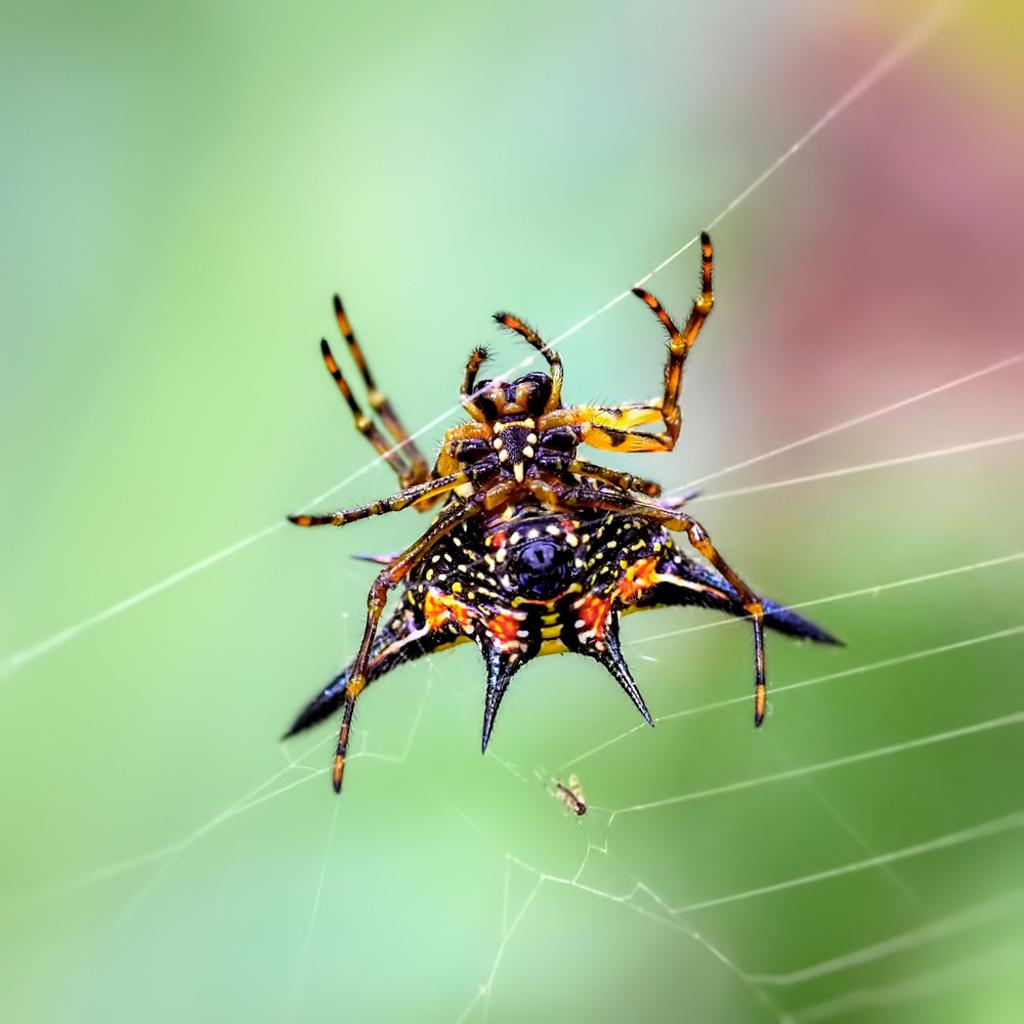What is the main subject of the image? The main subject of the image is a spider in a web. Where is the spider located in the image? The spider is in the web, which is in the center of the image. What type of cover does the sister use for the pail in the image? There is no sister, pail, or cover present in the image; it only features a spider in a web. 